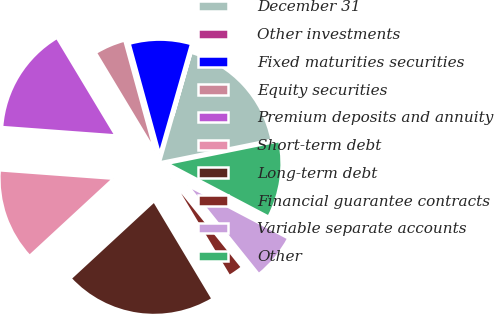<chart> <loc_0><loc_0><loc_500><loc_500><pie_chart><fcel>December 31<fcel>Other investments<fcel>Fixed maturities securities<fcel>Equity securities<fcel>Premium deposits and annuity<fcel>Short-term debt<fcel>Long-term debt<fcel>Financial guarantee contracts<fcel>Variable separate accounts<fcel>Other<nl><fcel>17.38%<fcel>0.01%<fcel>8.7%<fcel>4.36%<fcel>15.21%<fcel>13.04%<fcel>21.72%<fcel>2.18%<fcel>6.53%<fcel>10.87%<nl></chart> 